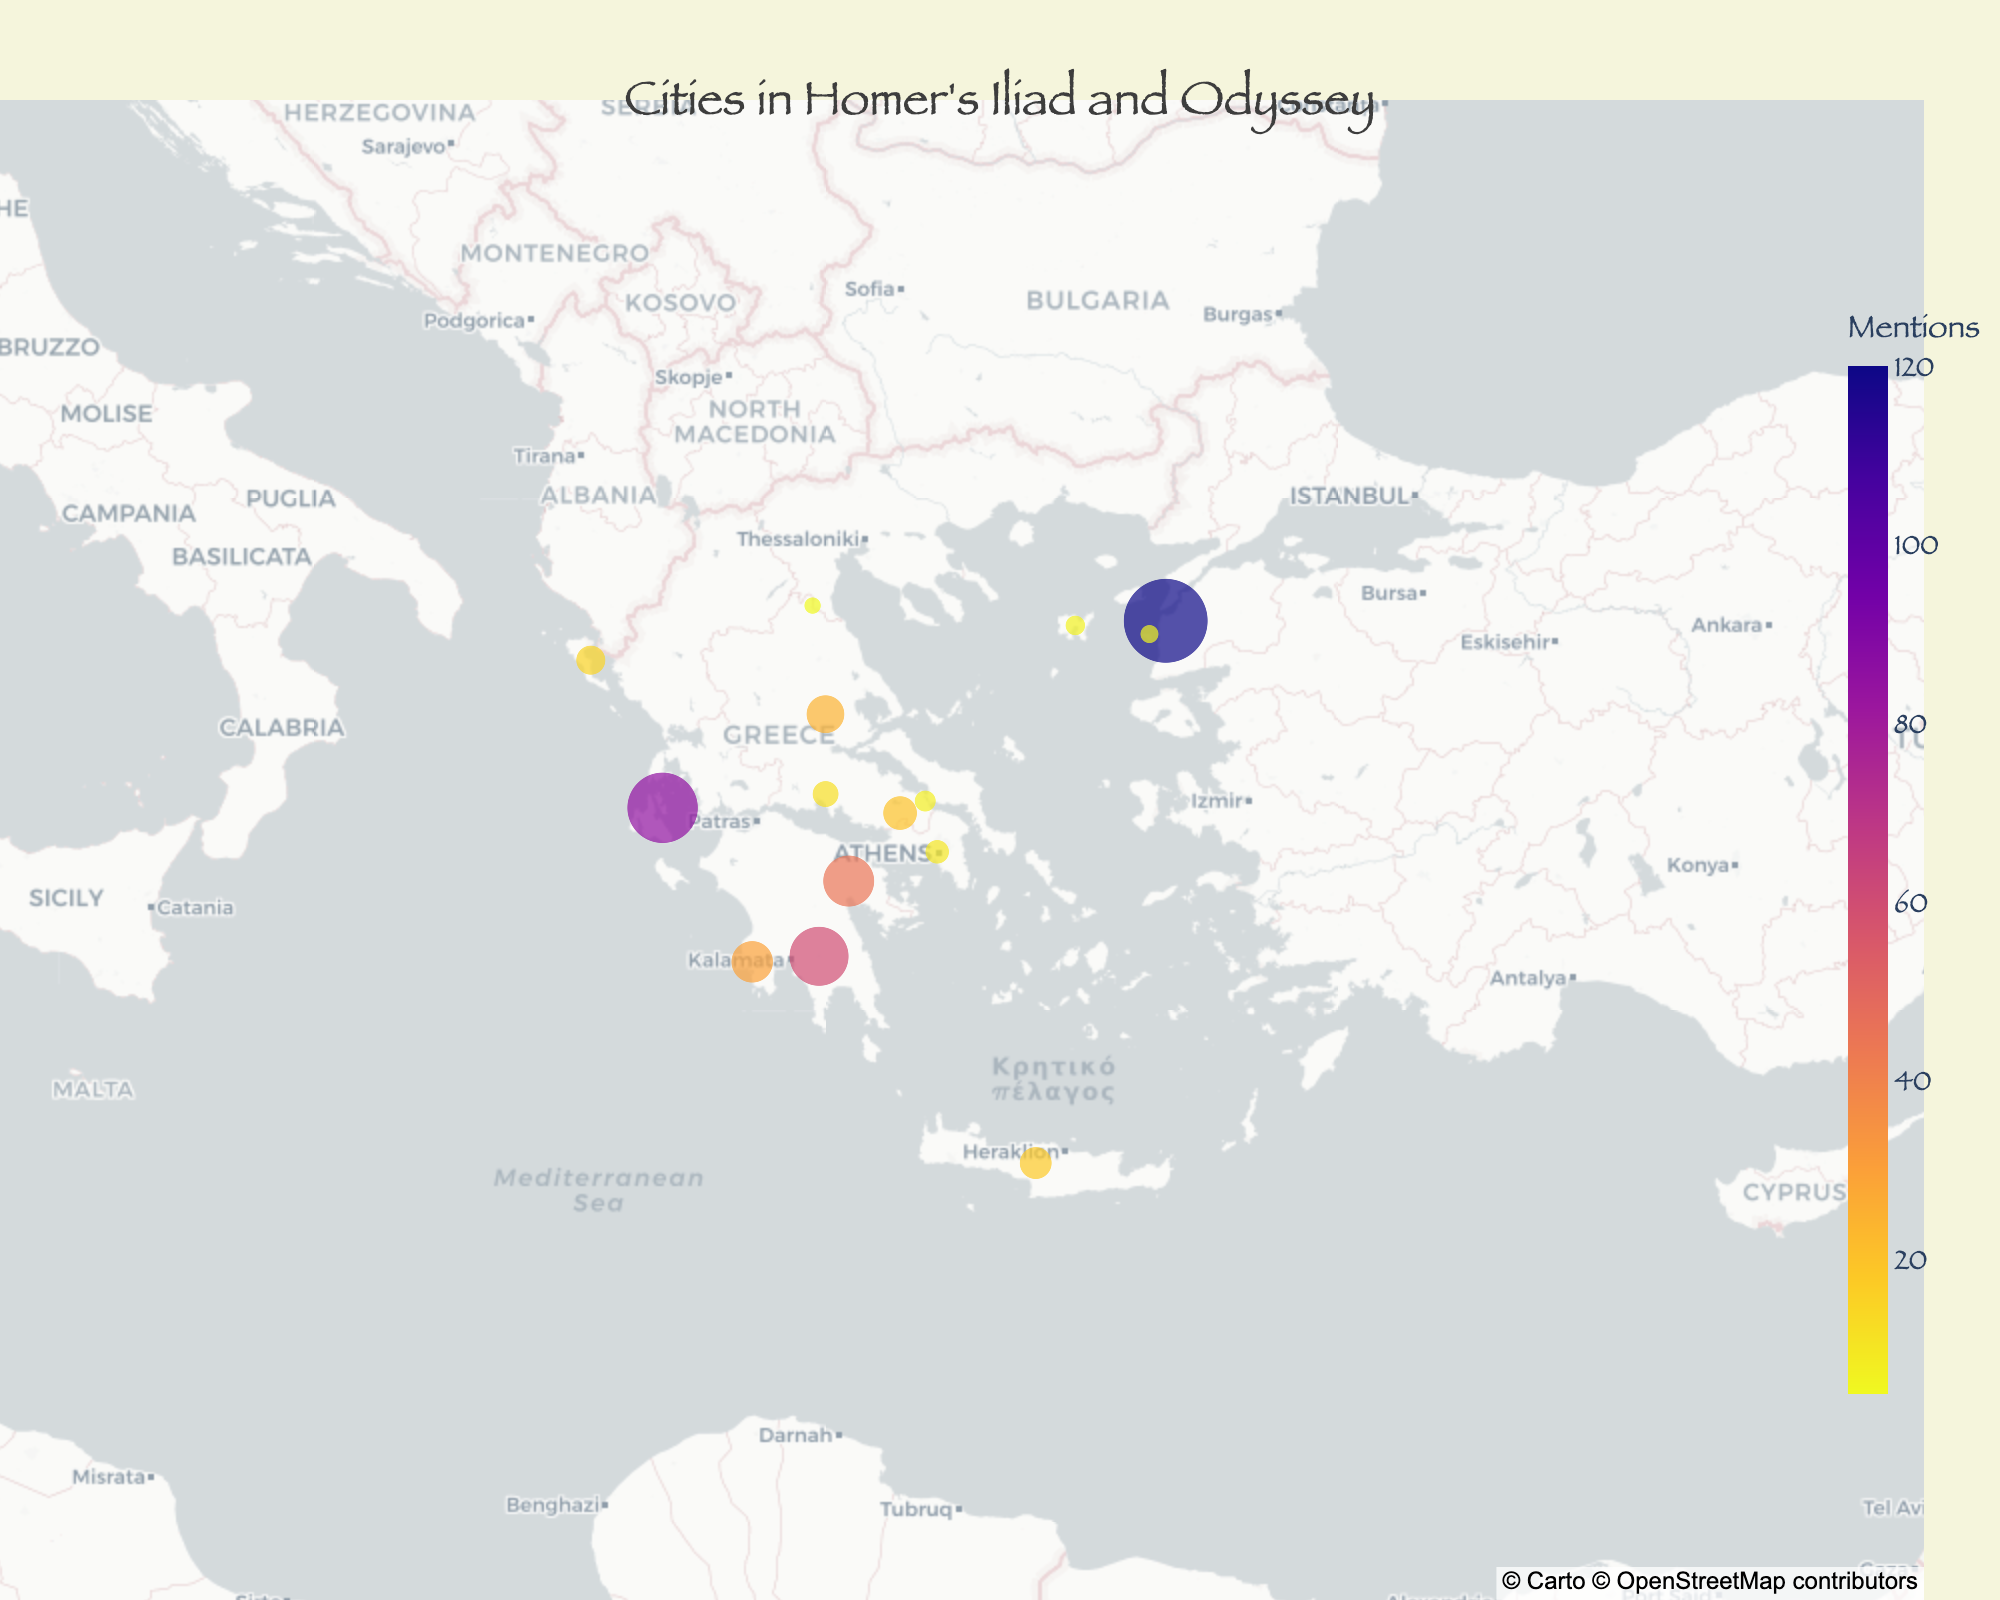What is the most mentioned city in Homer's Iliad and Odyssey? The most mentioned city can be determined by looking at the size and color intensity of the markers on the map. The largest and most intensely colored marker represents the city with the highest number of mentions.
Answer: Troy Which city is represented by the smallest marker on the map? The smallest marker indicates the city with the least number of mentions.
Answer: Olympus How many cities are marked on the map? By counting the number of distinct markers on the map, we can determine the total number of cities. There are 15 marked cities.
Answer: 15 Which city is located furthest to the north? By examining the latitude value, the city with the highest latitude is furthest to the north.
Answer: Olympus How does the number of mentions of Troy compare to that of Sparta? Comparing the size and color of their markers shows that Troy has significantly more mentions than Sparta. Troy's mentions are 120 while Sparta's are 60.
Answer: Troy has twice as many mentions as Sparta What is the average number of mentions for cities located south of 38 degrees latitude? First, identify the cities south of 38 degrees latitude: Sparta, Mycenae, Pylos, Crete, Athens. Sum their mentions (60 + 45 + 30 + 18 + 10 = 163). There are 5 cities, so the average is 163/5.
Answer: 32.6 Which city is situated closest to the center of the map (lat: 38, lon: 24)? The center point can be compared with the coordinates of each city. Mycenae (lat: 37.7306, lon: 22.7561) appears closest to the central coordinates.
Answer: Mycenae What is the total number of mentions for cities on the Greek mainland? Cities on the Greek mainland: Ithaca, Sparta, Mycenae, Pylos, Phthia, Thebes, Delphi, Athens, Aulis, Olympus. Summing their mentions (85 + 60 + 45 + 30 + 25 + 20 + 12 + 10 + 8 + 5).
Answer: 300 Which city has fewer mentions: Aulis or Tenedos? By comparing their mentions, Aulis has 8 and Tenedos has 6, thus Tenedos has fewer mentions.
Answer: Tenedos How many cities are mentioned more than 50 times? Troy, Ithaca, and Sparta are the cities with more than 50 mentions (120, 85, 60 respectively).
Answer: 3 